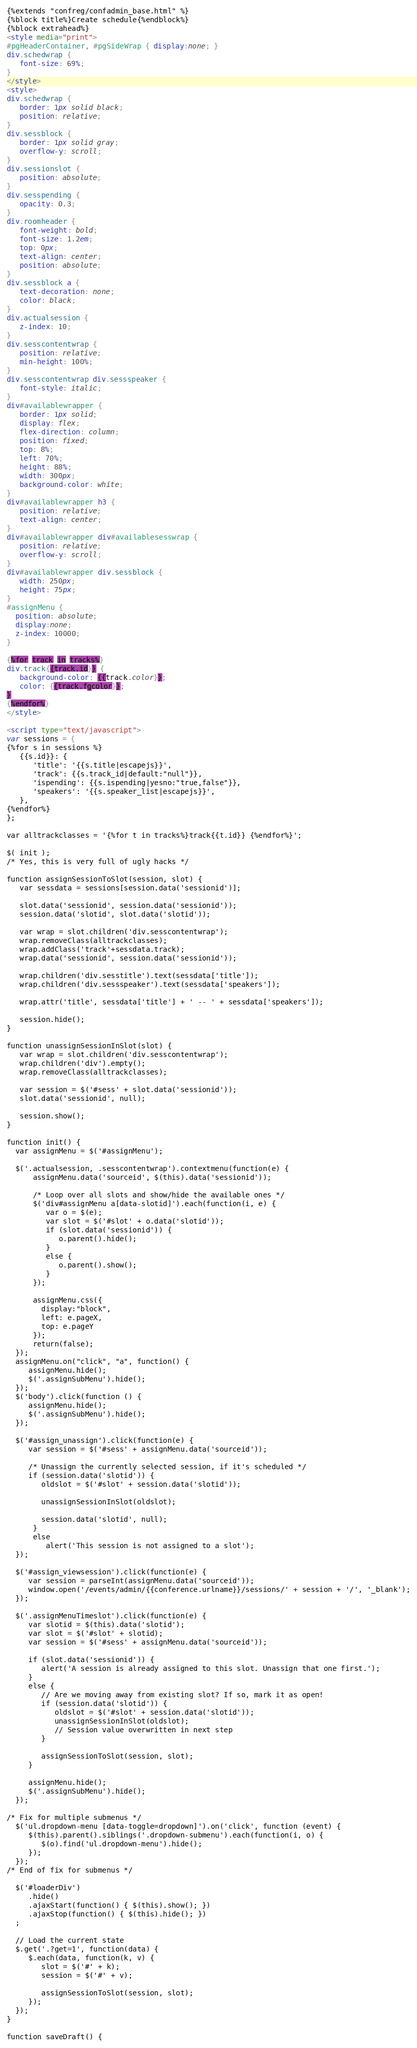Convert code to text. <code><loc_0><loc_0><loc_500><loc_500><_HTML_>{%extends "confreg/confadmin_base.html" %}
{%block title%}Create schedule{%endblock%}
{%block extrahead%}
<style media="print">
#pgHeaderContainer, #pgSideWrap { display:none; }
div.schedwrap {
   font-size: 69%;
}
</style>
<style>
div.schedwrap {
   border: 1px solid black;
   position: relative;
}
div.sessblock {
   border: 1px solid gray;
   overflow-y: scroll;
}
div.sessionslot {
   position: absolute;
}
div.sesspending {
   opacity: 0.3;
}
div.roomheader {
   font-weight: bold;
   font-size: 1.2em;
   top: 0px;
   text-align: center;
   position: absolute;
}
div.sessblock a {
   text-decoration: none;
   color: black;
}
div.actualsession {
   z-index: 10;
}
div.sesscontentwrap {
   position: relative;
   min-height: 100%;
}
div.sesscontentwrap div.sessspeaker {
   font-style: italic;
}
div#availablewrapper {
   border: 1px solid;
   display: flex;
   flex-direction: column;
   position: fixed;
   top: 8%;
   left: 70%;
   height: 88%;
   width: 300px;
   background-color: white;
}
div#availablewrapper h3 {
   position: relative;
   text-align: center;
}
div#availablewrapper div#availablesesswrap {
   position: relative;
   overflow-y: scroll;
}
div#availablewrapper div.sessblock {
   width: 250px;
   height: 75px;
}
#assignMenu {
  position: absolute;
  display:none;
  z-index: 10000;
}

{%for track in tracks%}
div.track{{track.id}} {
   background-color: {{track.color}};
   color: {{track.fgcolor}};
}
{%endfor%}
</style>

<script type="text/javascript">
var sessions = {
{%for s in sessions %}
   {{s.id}}: {
      'title': '{{s.title|escapejs}}',
      'track': {{s.track_id|default:"null"}},
      'ispending': {{s.ispending|yesno:"true,false"}},
      'speakers': '{{s.speaker_list|escapejs}}',
   },
{%endfor%}
};

var alltrackclasses = '{%for t in tracks%}track{{t.id}} {%endfor%}';

$( init );
/* Yes, this is very full of ugly hacks */

function assignSessionToSlot(session, slot) {
   var sessdata = sessions[session.data('sessionid')];

   slot.data('sessionid', session.data('sessionid'));
   session.data('slotid', slot.data('slotid'));

   var wrap = slot.children('div.sesscontentwrap');
   wrap.removeClass(alltrackclasses);
   wrap.addClass('track'+sessdata.track);
   wrap.data('sessionid', session.data('sessionid'));

   wrap.children('div.sesstitle').text(sessdata['title']);
   wrap.children('div.sessspeaker').text(sessdata['speakers']);

   wrap.attr('title', sessdata['title'] + ' -- ' + sessdata['speakers']);

   session.hide();
}

function unassignSessionInSlot(slot) {
   var wrap = slot.children('div.sesscontentwrap');
   wrap.children('div').empty();
   wrap.removeClass(alltrackclasses);

   var session = $('#sess' + slot.data('sessionid'));
   slot.data('sessionid', null);

   session.show();
}

function init() {
  var assignMenu = $('#assignMenu');

  $('.actualsession, .sesscontentwrap').contextmenu(function(e) {
      assignMenu.data('sourceid', $(this).data('sessionid'));

      /* Loop over all slots and show/hide the available ones */
      $('div#assignMenu a[data-slotid]').each(function(i, e) {
         var o = $(e);
         var slot = $('#slot' + o.data('slotid'));
         if (slot.data('sessionid')) {
            o.parent().hide();
         }
         else {
            o.parent().show();
         }
      });

      assignMenu.css({
        display:"block",
        left: e.pageX,
        top: e.pageY
      });
      return(false);
  });
  assignMenu.on("click", "a", function() {
     assignMenu.hide();
     $('.assignSubMenu').hide();
  });
  $('body').click(function () {
     assignMenu.hide();
     $('.assignSubMenu').hide();
  });

  $('#assign_unassign').click(function(e) {
     var session = $('#sess' + assignMenu.data('sourceid'));

     /* Unassign the currently selected session, if it's scheduled */
     if (session.data('slotid')) {
        oldslot = $('#slot' + session.data('slotid'));

        unassignSessionInSlot(oldslot);

        session.data('slotid', null);
      }
      else
         alert('This session is not assigned to a slot');
  });

  $('#assign_viewsession').click(function(e) {
     var session = parseInt(assignMenu.data('sourceid'));
     window.open('/events/admin/{{conference.urlname}}/sessions/' + session + '/', '_blank');
  });

  $('.assignMenuTimeslot').click(function(e) {
     var slotid = $(this).data('slotid');
     var slot = $('#slot' + slotid);
     var session = $('#sess' + assignMenu.data('sourceid'));

     if (slot.data('sessionid')) {
        alert('A session is already assigned to this slot. Unassign that one first.');
     }
     else {
        // Are we moving away from existing slot? If so, mark it as open!
        if (session.data('slotid')) {
           oldslot = $('#slot' + session.data('slotid'));
           unassignSessionInSlot(oldslot);
           // Session value overwritten in next step
        }

        assignSessionToSlot(session, slot);
     }

     assignMenu.hide();
     $('.assignSubMenu').hide();
  });

/* Fix for multiple submenus */
  $('ul.dropdown-menu [data-toggle=dropdown]').on('click', function (event) {
     $(this).parent().siblings('.dropdown-submenu').each(function(i, o) {
        $(o).find('ul.dropdown-menu').hide();
     });
  });
/* End of fix for submenus */

  $('#loaderDiv')
     .hide()
     .ajaxStart(function() { $(this).show(); })
     .ajaxStop(function() { $(this).hide(); })
  ;

  // Load the current state
  $.get('.?get=1', function(data) {
     $.each(data, function(k, v) {
        slot = $('#' + k);
        session = $('#' + v);

        assignSessionToSlot(session, slot);
     });
  });
}

function saveDraft() {</code> 